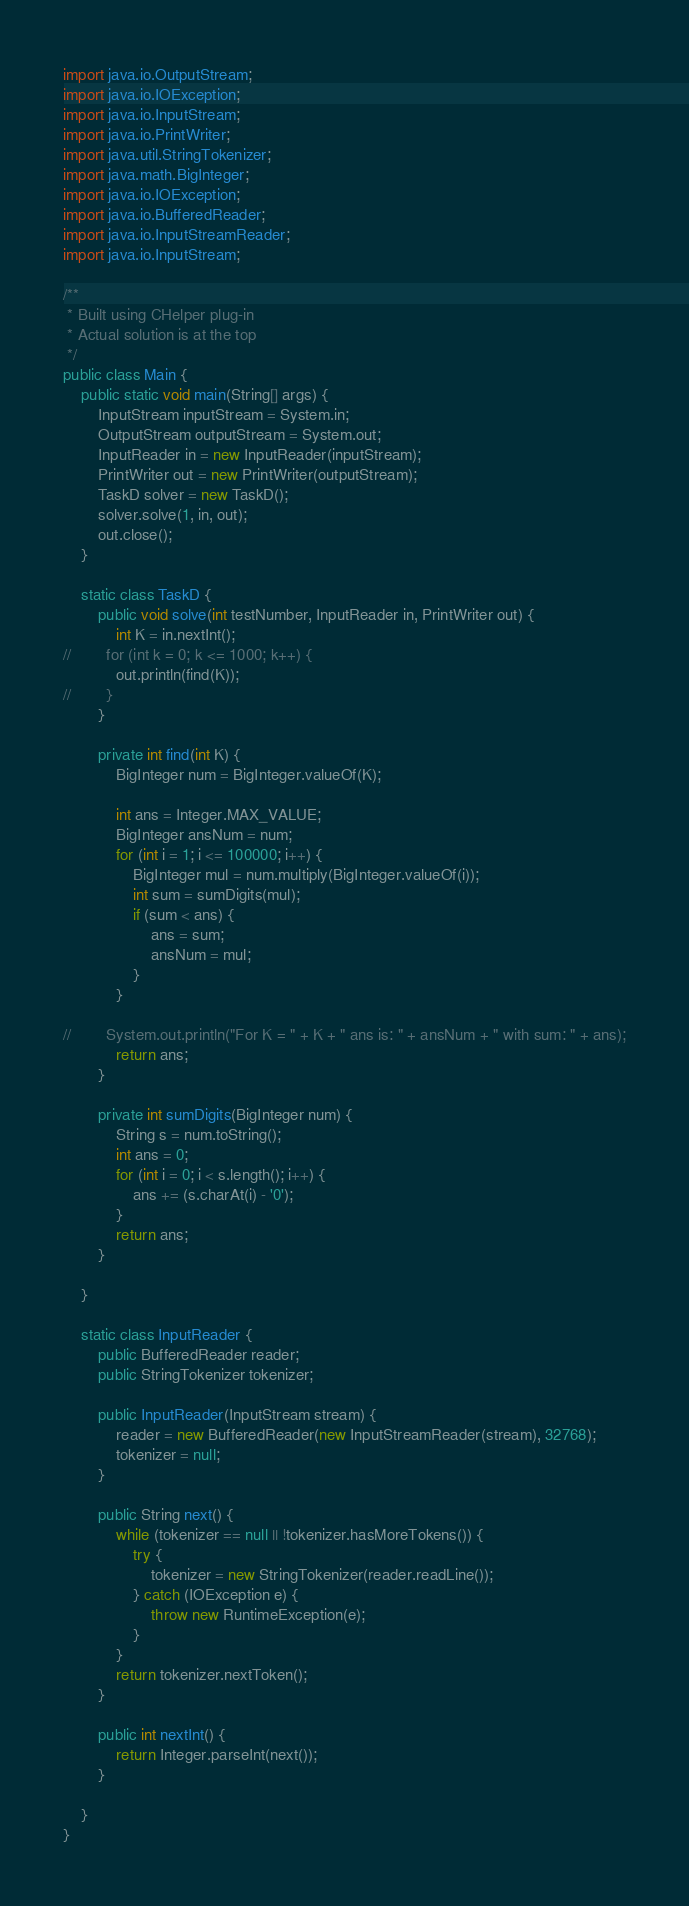Convert code to text. <code><loc_0><loc_0><loc_500><loc_500><_Java_>import java.io.OutputStream;
import java.io.IOException;
import java.io.InputStream;
import java.io.PrintWriter;
import java.util.StringTokenizer;
import java.math.BigInteger;
import java.io.IOException;
import java.io.BufferedReader;
import java.io.InputStreamReader;
import java.io.InputStream;

/**
 * Built using CHelper plug-in
 * Actual solution is at the top
 */
public class Main {
    public static void main(String[] args) {
        InputStream inputStream = System.in;
        OutputStream outputStream = System.out;
        InputReader in = new InputReader(inputStream);
        PrintWriter out = new PrintWriter(outputStream);
        TaskD solver = new TaskD();
        solver.solve(1, in, out);
        out.close();
    }

    static class TaskD {
        public void solve(int testNumber, InputReader in, PrintWriter out) {
            int K = in.nextInt();
//        for (int k = 0; k <= 1000; k++) {
            out.println(find(K));
//        }
        }

        private int find(int K) {
            BigInteger num = BigInteger.valueOf(K);

            int ans = Integer.MAX_VALUE;
            BigInteger ansNum = num;
            for (int i = 1; i <= 100000; i++) {
                BigInteger mul = num.multiply(BigInteger.valueOf(i));
                int sum = sumDigits(mul);
                if (sum < ans) {
                    ans = sum;
                    ansNum = mul;
                }
            }

//        System.out.println("For K = " + K + " ans is: " + ansNum + " with sum: " + ans);
            return ans;
        }

        private int sumDigits(BigInteger num) {
            String s = num.toString();
            int ans = 0;
            for (int i = 0; i < s.length(); i++) {
                ans += (s.charAt(i) - '0');
            }
            return ans;
        }

    }

    static class InputReader {
        public BufferedReader reader;
        public StringTokenizer tokenizer;

        public InputReader(InputStream stream) {
            reader = new BufferedReader(new InputStreamReader(stream), 32768);
            tokenizer = null;
        }

        public String next() {
            while (tokenizer == null || !tokenizer.hasMoreTokens()) {
                try {
                    tokenizer = new StringTokenizer(reader.readLine());
                } catch (IOException e) {
                    throw new RuntimeException(e);
                }
            }
            return tokenizer.nextToken();
        }

        public int nextInt() {
            return Integer.parseInt(next());
        }

    }
}

</code> 